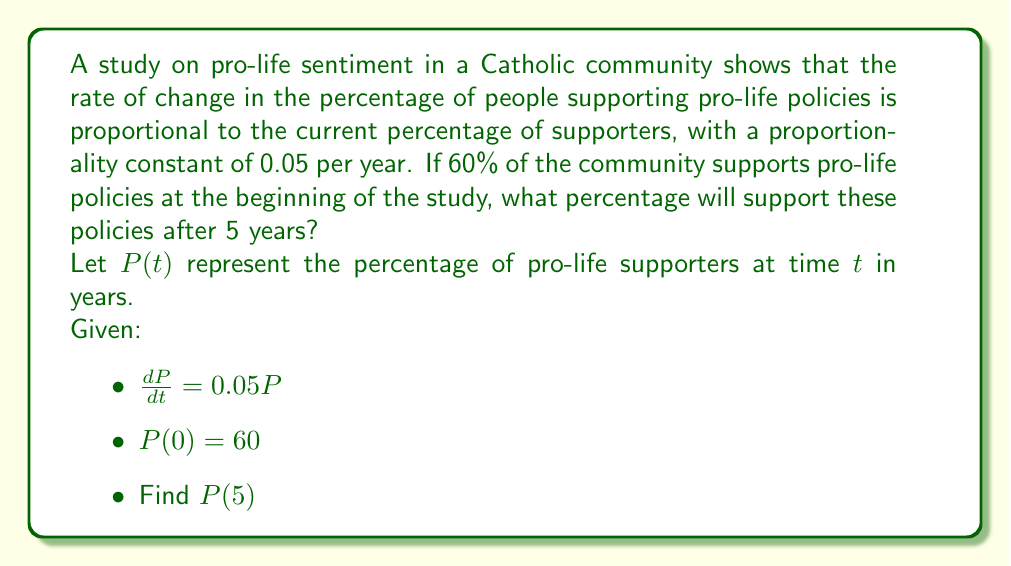Could you help me with this problem? To solve this first-order differential equation:

1) The general solution for $\frac{dP}{dt} = kP$ is $P(t) = Ce^{kt}$, where $C$ is a constant.

2) In this case, $k = 0.05$, so our general solution is:
   $P(t) = Ce^{0.05t}$

3) To find $C$, we use the initial condition $P(0) = 60$:
   $60 = Ce^{0.05(0)}$
   $60 = C$

4) Now we have the particular solution:
   $P(t) = 60e^{0.05t}$

5) To find $P(5)$, we substitute $t = 5$:
   $P(5) = 60e^{0.05(5)}$
   $P(5) = 60e^{0.25}$

6) Calculate the result:
   $P(5) = 60 \times 1.2840 \approx 77.04$

Therefore, after 5 years, approximately 77.04% of the community will support pro-life policies.
Answer: $P(5) \approx 77.04\%$ 